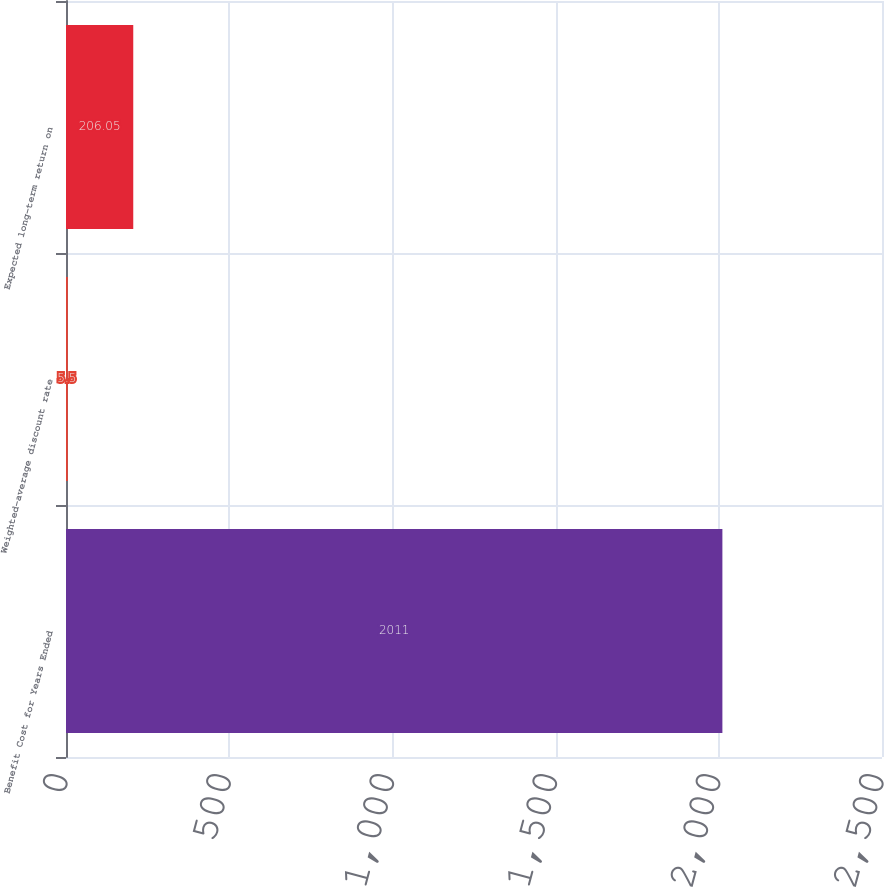Convert chart. <chart><loc_0><loc_0><loc_500><loc_500><bar_chart><fcel>Benefit Cost for Years Ended<fcel>Weighted-average discount rate<fcel>Expected long-term return on<nl><fcel>2011<fcel>5.5<fcel>206.05<nl></chart> 